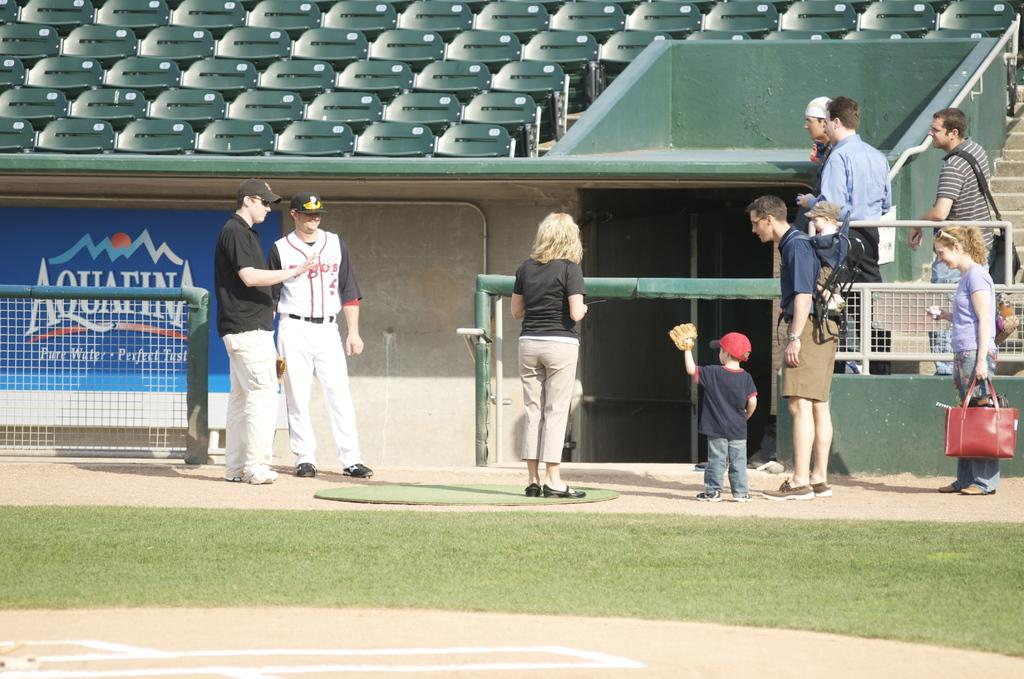<image>
Share a concise interpretation of the image provided. An advertisement for Aquafina water hangs near the dugout of a baseball field. 